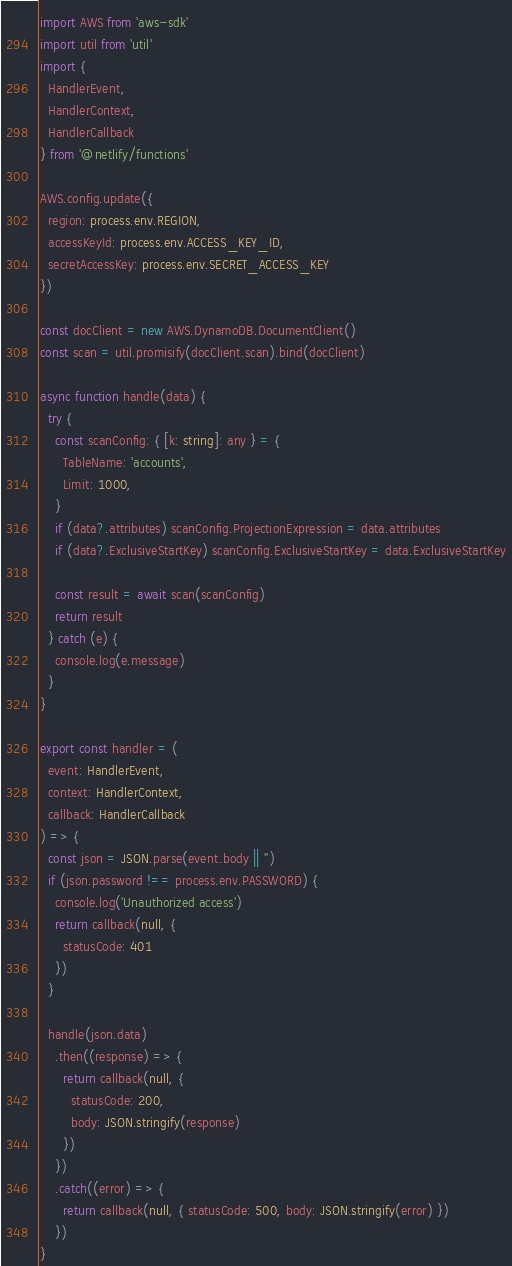<code> <loc_0><loc_0><loc_500><loc_500><_TypeScript_>import AWS from 'aws-sdk'
import util from 'util'
import {
  HandlerEvent,
  HandlerContext,
  HandlerCallback
} from '@netlify/functions'

AWS.config.update({
  region: process.env.REGION,
  accessKeyId: process.env.ACCESS_KEY_ID,
  secretAccessKey: process.env.SECRET_ACCESS_KEY
})

const docClient = new AWS.DynamoDB.DocumentClient()
const scan = util.promisify(docClient.scan).bind(docClient)

async function handle(data) {
  try {
    const scanConfig: { [k: string]: any } = {
      TableName: 'accounts',
      Limit: 1000,
    }
    if (data?.attributes) scanConfig.ProjectionExpression = data.attributes
    if (data?.ExclusiveStartKey) scanConfig.ExclusiveStartKey = data.ExclusiveStartKey

    const result = await scan(scanConfig)
    return result
  } catch (e) {
    console.log(e.message)
  }
}

export const handler = (
  event: HandlerEvent,
  context: HandlerContext,
  callback: HandlerCallback
) => {
  const json = JSON.parse(event.body || '')
  if (json.password !== process.env.PASSWORD) {
    console.log('Unauthorized access')
    return callback(null, {
      statusCode: 401
    })
  }

  handle(json.data)
    .then((response) => {
      return callback(null, {
        statusCode: 200,
        body: JSON.stringify(response)
      })
    })
    .catch((error) => {
      return callback(null, { statusCode: 500, body: JSON.stringify(error) })
    })
}
</code> 